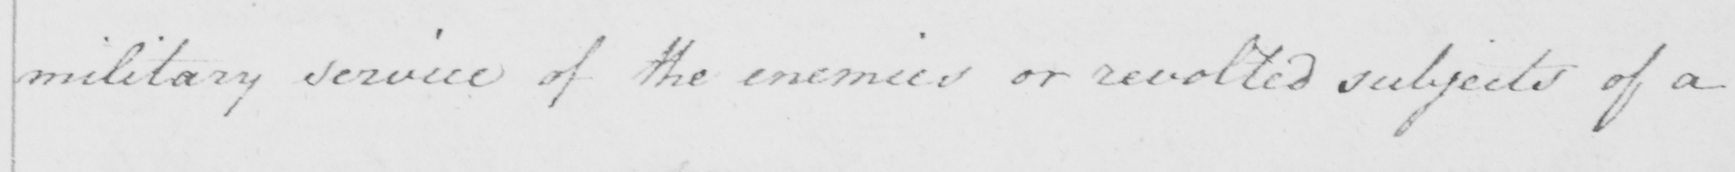Please transcribe the handwritten text in this image. military service of the enemies or revolted subjects of a 